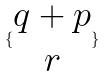Convert formula to latex. <formula><loc_0><loc_0><loc_500><loc_500>\{ \begin{matrix} q + p \\ r \end{matrix} \}</formula> 